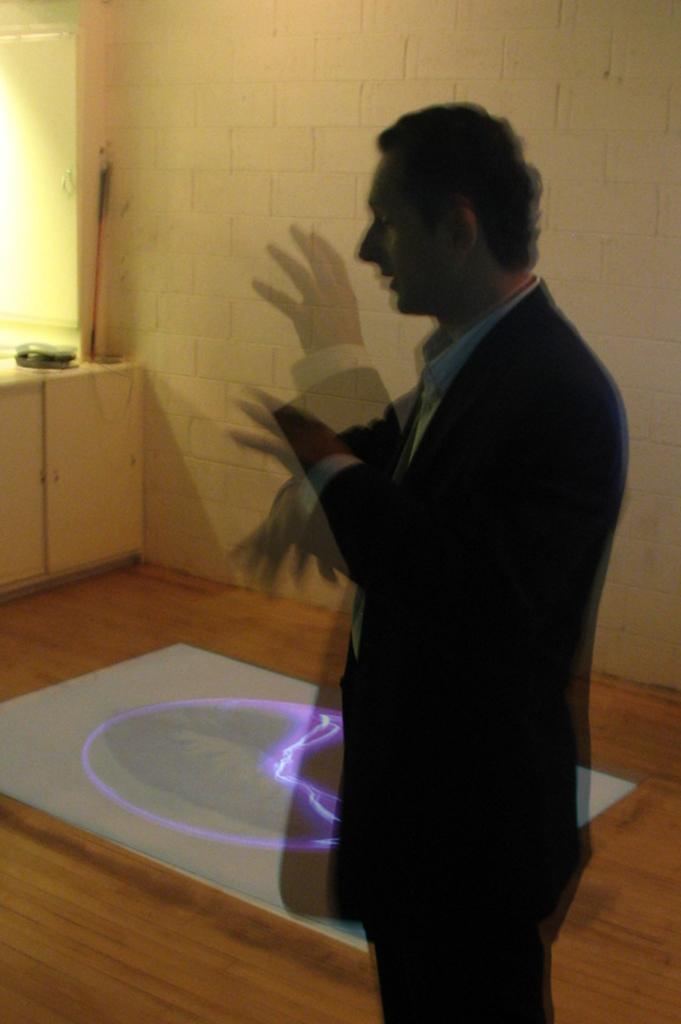Please provide a concise description of this image. In this picture I can see a person standing, side there is a brick wall. 